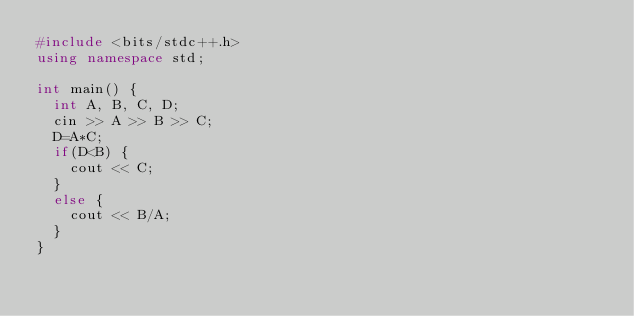<code> <loc_0><loc_0><loc_500><loc_500><_C++_>#include <bits/stdc++.h>
using namespace std;
 
int main() {
  int A, B, C, D;
  cin >> A >> B >> C;
  D=A*C;
  if(D<B) {
    cout << C;
  }
  else {
    cout << B/A;
  }
}</code> 